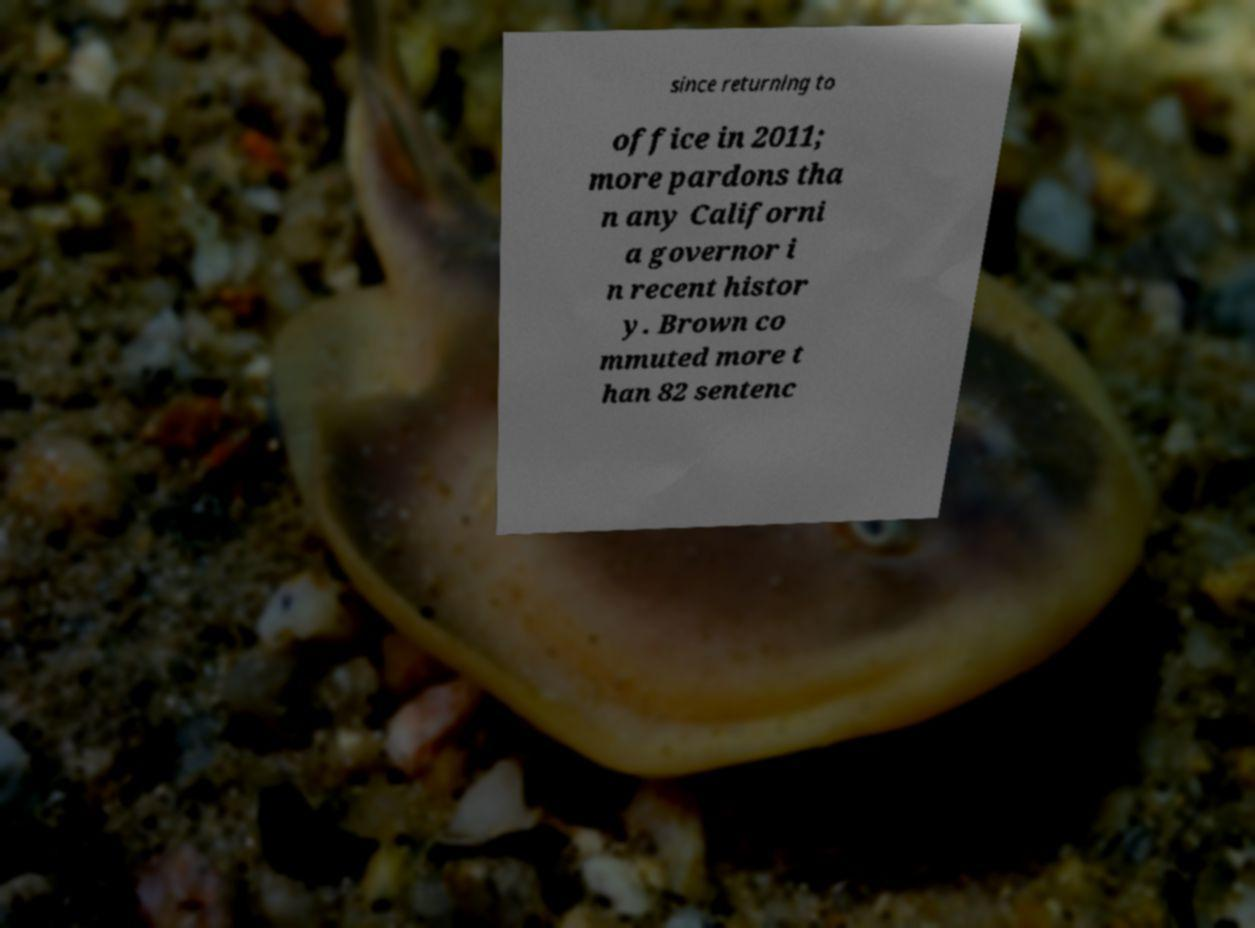There's text embedded in this image that I need extracted. Can you transcribe it verbatim? since returning to office in 2011; more pardons tha n any Californi a governor i n recent histor y. Brown co mmuted more t han 82 sentenc 